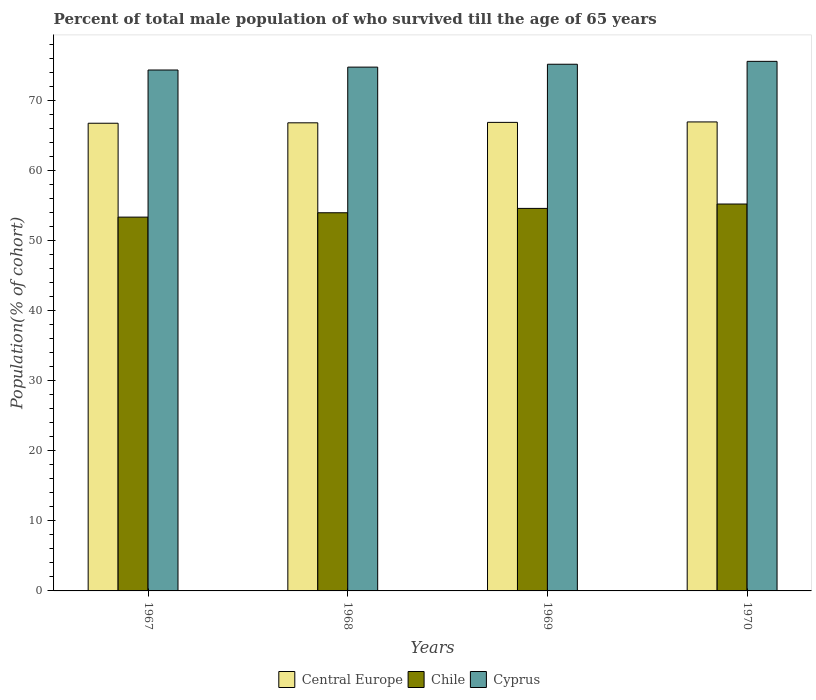How many different coloured bars are there?
Your response must be concise. 3. How many groups of bars are there?
Provide a short and direct response. 4. Are the number of bars on each tick of the X-axis equal?
Provide a short and direct response. Yes. How many bars are there on the 4th tick from the left?
Provide a short and direct response. 3. How many bars are there on the 1st tick from the right?
Your response must be concise. 3. What is the label of the 3rd group of bars from the left?
Offer a very short reply. 1969. What is the percentage of total male population who survived till the age of 65 years in Cyprus in 1967?
Your answer should be very brief. 74.3. Across all years, what is the maximum percentage of total male population who survived till the age of 65 years in Cyprus?
Keep it short and to the point. 75.54. Across all years, what is the minimum percentage of total male population who survived till the age of 65 years in Cyprus?
Offer a very short reply. 74.3. In which year was the percentage of total male population who survived till the age of 65 years in Chile maximum?
Your answer should be compact. 1970. In which year was the percentage of total male population who survived till the age of 65 years in Cyprus minimum?
Ensure brevity in your answer.  1967. What is the total percentage of total male population who survived till the age of 65 years in Cyprus in the graph?
Ensure brevity in your answer.  299.69. What is the difference between the percentage of total male population who survived till the age of 65 years in Chile in 1967 and that in 1968?
Your response must be concise. -0.62. What is the difference between the percentage of total male population who survived till the age of 65 years in Chile in 1968 and the percentage of total male population who survived till the age of 65 years in Central Europe in 1969?
Your response must be concise. -12.89. What is the average percentage of total male population who survived till the age of 65 years in Chile per year?
Your response must be concise. 54.25. In the year 1967, what is the difference between the percentage of total male population who survived till the age of 65 years in Cyprus and percentage of total male population who survived till the age of 65 years in Chile?
Offer a terse response. 20.98. In how many years, is the percentage of total male population who survived till the age of 65 years in Chile greater than 46 %?
Keep it short and to the point. 4. What is the ratio of the percentage of total male population who survived till the age of 65 years in Cyprus in 1969 to that in 1970?
Offer a very short reply. 0.99. What is the difference between the highest and the second highest percentage of total male population who survived till the age of 65 years in Chile?
Your answer should be compact. 0.62. What is the difference between the highest and the lowest percentage of total male population who survived till the age of 65 years in Chile?
Your response must be concise. 1.87. What does the 3rd bar from the right in 1969 represents?
Your answer should be very brief. Central Europe. What is the difference between two consecutive major ticks on the Y-axis?
Provide a succinct answer. 10. Are the values on the major ticks of Y-axis written in scientific E-notation?
Ensure brevity in your answer.  No. Where does the legend appear in the graph?
Make the answer very short. Bottom center. How many legend labels are there?
Provide a short and direct response. 3. How are the legend labels stacked?
Your answer should be very brief. Horizontal. What is the title of the graph?
Your answer should be very brief. Percent of total male population of who survived till the age of 65 years. What is the label or title of the Y-axis?
Ensure brevity in your answer.  Population(% of cohort). What is the Population(% of cohort) of Central Europe in 1967?
Your response must be concise. 66.71. What is the Population(% of cohort) in Chile in 1967?
Ensure brevity in your answer.  53.32. What is the Population(% of cohort) in Cyprus in 1967?
Offer a terse response. 74.3. What is the Population(% of cohort) in Central Europe in 1968?
Your answer should be compact. 66.77. What is the Population(% of cohort) in Chile in 1968?
Offer a terse response. 53.94. What is the Population(% of cohort) in Cyprus in 1968?
Your answer should be compact. 74.72. What is the Population(% of cohort) in Central Europe in 1969?
Keep it short and to the point. 66.83. What is the Population(% of cohort) of Chile in 1969?
Give a very brief answer. 54.57. What is the Population(% of cohort) in Cyprus in 1969?
Provide a short and direct response. 75.13. What is the Population(% of cohort) in Central Europe in 1970?
Keep it short and to the point. 66.9. What is the Population(% of cohort) of Chile in 1970?
Offer a very short reply. 55.19. What is the Population(% of cohort) in Cyprus in 1970?
Offer a terse response. 75.54. Across all years, what is the maximum Population(% of cohort) of Central Europe?
Provide a short and direct response. 66.9. Across all years, what is the maximum Population(% of cohort) in Chile?
Provide a short and direct response. 55.19. Across all years, what is the maximum Population(% of cohort) in Cyprus?
Your answer should be compact. 75.54. Across all years, what is the minimum Population(% of cohort) in Central Europe?
Provide a short and direct response. 66.71. Across all years, what is the minimum Population(% of cohort) in Chile?
Provide a short and direct response. 53.32. Across all years, what is the minimum Population(% of cohort) of Cyprus?
Offer a very short reply. 74.3. What is the total Population(% of cohort) of Central Europe in the graph?
Your answer should be very brief. 267.22. What is the total Population(% of cohort) in Chile in the graph?
Provide a succinct answer. 217.02. What is the total Population(% of cohort) of Cyprus in the graph?
Offer a terse response. 299.69. What is the difference between the Population(% of cohort) in Central Europe in 1967 and that in 1968?
Your answer should be compact. -0.06. What is the difference between the Population(% of cohort) of Chile in 1967 and that in 1968?
Offer a terse response. -0.62. What is the difference between the Population(% of cohort) of Cyprus in 1967 and that in 1968?
Your answer should be very brief. -0.41. What is the difference between the Population(% of cohort) in Central Europe in 1967 and that in 1969?
Ensure brevity in your answer.  -0.12. What is the difference between the Population(% of cohort) of Chile in 1967 and that in 1969?
Keep it short and to the point. -1.24. What is the difference between the Population(% of cohort) in Cyprus in 1967 and that in 1969?
Your answer should be compact. -0.82. What is the difference between the Population(% of cohort) in Central Europe in 1967 and that in 1970?
Your response must be concise. -0.19. What is the difference between the Population(% of cohort) of Chile in 1967 and that in 1970?
Your answer should be compact. -1.87. What is the difference between the Population(% of cohort) of Cyprus in 1967 and that in 1970?
Keep it short and to the point. -1.23. What is the difference between the Population(% of cohort) in Central Europe in 1968 and that in 1969?
Offer a terse response. -0.06. What is the difference between the Population(% of cohort) of Chile in 1968 and that in 1969?
Offer a terse response. -0.62. What is the difference between the Population(% of cohort) of Cyprus in 1968 and that in 1969?
Offer a very short reply. -0.41. What is the difference between the Population(% of cohort) in Central Europe in 1968 and that in 1970?
Your answer should be compact. -0.13. What is the difference between the Population(% of cohort) in Chile in 1968 and that in 1970?
Give a very brief answer. -1.24. What is the difference between the Population(% of cohort) of Cyprus in 1968 and that in 1970?
Offer a terse response. -0.82. What is the difference between the Population(% of cohort) in Central Europe in 1969 and that in 1970?
Your answer should be very brief. -0.06. What is the difference between the Population(% of cohort) of Chile in 1969 and that in 1970?
Provide a succinct answer. -0.62. What is the difference between the Population(% of cohort) of Cyprus in 1969 and that in 1970?
Make the answer very short. -0.41. What is the difference between the Population(% of cohort) in Central Europe in 1967 and the Population(% of cohort) in Chile in 1968?
Your answer should be very brief. 12.77. What is the difference between the Population(% of cohort) of Central Europe in 1967 and the Population(% of cohort) of Cyprus in 1968?
Offer a terse response. -8. What is the difference between the Population(% of cohort) in Chile in 1967 and the Population(% of cohort) in Cyprus in 1968?
Your answer should be very brief. -21.4. What is the difference between the Population(% of cohort) of Central Europe in 1967 and the Population(% of cohort) of Chile in 1969?
Keep it short and to the point. 12.15. What is the difference between the Population(% of cohort) in Central Europe in 1967 and the Population(% of cohort) in Cyprus in 1969?
Your answer should be very brief. -8.42. What is the difference between the Population(% of cohort) in Chile in 1967 and the Population(% of cohort) in Cyprus in 1969?
Give a very brief answer. -21.81. What is the difference between the Population(% of cohort) in Central Europe in 1967 and the Population(% of cohort) in Chile in 1970?
Provide a succinct answer. 11.52. What is the difference between the Population(% of cohort) of Central Europe in 1967 and the Population(% of cohort) of Cyprus in 1970?
Provide a succinct answer. -8.83. What is the difference between the Population(% of cohort) of Chile in 1967 and the Population(% of cohort) of Cyprus in 1970?
Give a very brief answer. -22.22. What is the difference between the Population(% of cohort) in Central Europe in 1968 and the Population(% of cohort) in Chile in 1969?
Provide a short and direct response. 12.21. What is the difference between the Population(% of cohort) in Central Europe in 1968 and the Population(% of cohort) in Cyprus in 1969?
Your answer should be very brief. -8.36. What is the difference between the Population(% of cohort) in Chile in 1968 and the Population(% of cohort) in Cyprus in 1969?
Keep it short and to the point. -21.18. What is the difference between the Population(% of cohort) of Central Europe in 1968 and the Population(% of cohort) of Chile in 1970?
Provide a succinct answer. 11.58. What is the difference between the Population(% of cohort) of Central Europe in 1968 and the Population(% of cohort) of Cyprus in 1970?
Provide a short and direct response. -8.77. What is the difference between the Population(% of cohort) in Chile in 1968 and the Population(% of cohort) in Cyprus in 1970?
Offer a terse response. -21.6. What is the difference between the Population(% of cohort) of Central Europe in 1969 and the Population(% of cohort) of Chile in 1970?
Give a very brief answer. 11.65. What is the difference between the Population(% of cohort) of Central Europe in 1969 and the Population(% of cohort) of Cyprus in 1970?
Offer a terse response. -8.7. What is the difference between the Population(% of cohort) in Chile in 1969 and the Population(% of cohort) in Cyprus in 1970?
Your answer should be very brief. -20.97. What is the average Population(% of cohort) in Central Europe per year?
Your answer should be very brief. 66.8. What is the average Population(% of cohort) of Chile per year?
Your response must be concise. 54.25. What is the average Population(% of cohort) in Cyprus per year?
Your response must be concise. 74.92. In the year 1967, what is the difference between the Population(% of cohort) in Central Europe and Population(% of cohort) in Chile?
Provide a short and direct response. 13.39. In the year 1967, what is the difference between the Population(% of cohort) in Central Europe and Population(% of cohort) in Cyprus?
Provide a succinct answer. -7.59. In the year 1967, what is the difference between the Population(% of cohort) in Chile and Population(% of cohort) in Cyprus?
Offer a terse response. -20.98. In the year 1968, what is the difference between the Population(% of cohort) of Central Europe and Population(% of cohort) of Chile?
Your answer should be very brief. 12.83. In the year 1968, what is the difference between the Population(% of cohort) in Central Europe and Population(% of cohort) in Cyprus?
Provide a succinct answer. -7.94. In the year 1968, what is the difference between the Population(% of cohort) in Chile and Population(% of cohort) in Cyprus?
Offer a terse response. -20.77. In the year 1969, what is the difference between the Population(% of cohort) in Central Europe and Population(% of cohort) in Chile?
Keep it short and to the point. 12.27. In the year 1969, what is the difference between the Population(% of cohort) of Central Europe and Population(% of cohort) of Cyprus?
Your answer should be compact. -8.29. In the year 1969, what is the difference between the Population(% of cohort) in Chile and Population(% of cohort) in Cyprus?
Provide a short and direct response. -20.56. In the year 1970, what is the difference between the Population(% of cohort) of Central Europe and Population(% of cohort) of Chile?
Your response must be concise. 11.71. In the year 1970, what is the difference between the Population(% of cohort) in Central Europe and Population(% of cohort) in Cyprus?
Your answer should be compact. -8.64. In the year 1970, what is the difference between the Population(% of cohort) in Chile and Population(% of cohort) in Cyprus?
Provide a short and direct response. -20.35. What is the ratio of the Population(% of cohort) in Central Europe in 1967 to that in 1968?
Offer a terse response. 1. What is the ratio of the Population(% of cohort) in Central Europe in 1967 to that in 1969?
Provide a short and direct response. 1. What is the ratio of the Population(% of cohort) of Chile in 1967 to that in 1969?
Your response must be concise. 0.98. What is the ratio of the Population(% of cohort) of Chile in 1967 to that in 1970?
Keep it short and to the point. 0.97. What is the ratio of the Population(% of cohort) in Cyprus in 1967 to that in 1970?
Ensure brevity in your answer.  0.98. What is the ratio of the Population(% of cohort) in Central Europe in 1968 to that in 1969?
Offer a terse response. 1. What is the ratio of the Population(% of cohort) of Cyprus in 1968 to that in 1969?
Keep it short and to the point. 0.99. What is the ratio of the Population(% of cohort) in Central Europe in 1968 to that in 1970?
Keep it short and to the point. 1. What is the ratio of the Population(% of cohort) in Chile in 1968 to that in 1970?
Your answer should be compact. 0.98. What is the ratio of the Population(% of cohort) in Chile in 1969 to that in 1970?
Your answer should be compact. 0.99. What is the difference between the highest and the second highest Population(% of cohort) in Central Europe?
Your answer should be very brief. 0.06. What is the difference between the highest and the second highest Population(% of cohort) in Chile?
Ensure brevity in your answer.  0.62. What is the difference between the highest and the second highest Population(% of cohort) of Cyprus?
Keep it short and to the point. 0.41. What is the difference between the highest and the lowest Population(% of cohort) in Central Europe?
Provide a succinct answer. 0.19. What is the difference between the highest and the lowest Population(% of cohort) of Chile?
Your response must be concise. 1.87. What is the difference between the highest and the lowest Population(% of cohort) of Cyprus?
Your answer should be very brief. 1.23. 